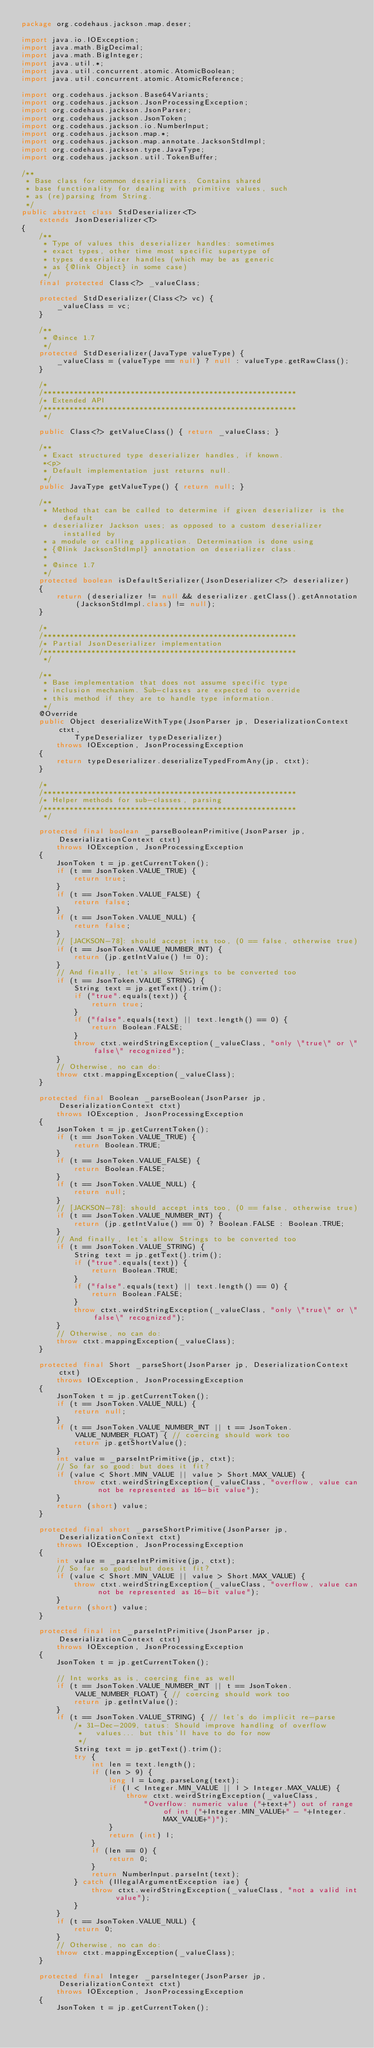<code> <loc_0><loc_0><loc_500><loc_500><_Java_>package org.codehaus.jackson.map.deser;

import java.io.IOException;
import java.math.BigDecimal;
import java.math.BigInteger;
import java.util.*;
import java.util.concurrent.atomic.AtomicBoolean;
import java.util.concurrent.atomic.AtomicReference;

import org.codehaus.jackson.Base64Variants;
import org.codehaus.jackson.JsonProcessingException;
import org.codehaus.jackson.JsonParser;
import org.codehaus.jackson.JsonToken;
import org.codehaus.jackson.io.NumberInput;
import org.codehaus.jackson.map.*;
import org.codehaus.jackson.map.annotate.JacksonStdImpl;
import org.codehaus.jackson.type.JavaType;
import org.codehaus.jackson.util.TokenBuffer;

/**
 * Base class for common deserializers. Contains shared
 * base functionality for dealing with primitive values, such
 * as (re)parsing from String.
 */
public abstract class StdDeserializer<T>
    extends JsonDeserializer<T>
{
    /**
     * Type of values this deserializer handles: sometimes
     * exact types, other time most specific supertype of
     * types deserializer handles (which may be as generic
     * as {@link Object} in some case)
     */
    final protected Class<?> _valueClass;

    protected StdDeserializer(Class<?> vc) {
        _valueClass = vc;
    }

    /**
     * @since 1.7
     */
    protected StdDeserializer(JavaType valueType) {
        _valueClass = (valueType == null) ? null : valueType.getRawClass();
    }
    
    /*
    /**********************************************************
    /* Extended API
    /**********************************************************
     */

    public Class<?> getValueClass() { return _valueClass; }

    /**
     * Exact structured type deserializer handles, if known.
     *<p>
     * Default implementation just returns null.
     */
    public JavaType getValueType() { return null; }

    /**
     * Method that can be called to determine if given deserializer is the default
     * deserializer Jackson uses; as opposed to a custom deserializer installed by
     * a module or calling application. Determination is done using
     * {@link JacksonStdImpl} annotation on deserializer class.
     * 
     * @since 1.7
     */
    protected boolean isDefaultSerializer(JsonDeserializer<?> deserializer)
    {
        return (deserializer != null && deserializer.getClass().getAnnotation(JacksonStdImpl.class) != null);
    }
    
    /*
    /**********************************************************
    /* Partial JsonDeserializer implementation 
    /**********************************************************
     */
    
    /**
     * Base implementation that does not assume specific type
     * inclusion mechanism. Sub-classes are expected to override
     * this method if they are to handle type information.
     */
    @Override
    public Object deserializeWithType(JsonParser jp, DeserializationContext ctxt,
            TypeDeserializer typeDeserializer)
        throws IOException, JsonProcessingException
    {
        return typeDeserializer.deserializeTypedFromAny(jp, ctxt);
    }
    
    /*
    /**********************************************************
    /* Helper methods for sub-classes, parsing
    /**********************************************************
     */

    protected final boolean _parseBooleanPrimitive(JsonParser jp, DeserializationContext ctxt)
        throws IOException, JsonProcessingException
    {
        JsonToken t = jp.getCurrentToken();
        if (t == JsonToken.VALUE_TRUE) {
            return true;
        }
        if (t == JsonToken.VALUE_FALSE) {
            return false;
        }
        if (t == JsonToken.VALUE_NULL) {
            return false;
        }
        // [JACKSON-78]: should accept ints too, (0 == false, otherwise true)
        if (t == JsonToken.VALUE_NUMBER_INT) {
            return (jp.getIntValue() != 0);
        }
        // And finally, let's allow Strings to be converted too
        if (t == JsonToken.VALUE_STRING) {
            String text = jp.getText().trim();
            if ("true".equals(text)) {
                return true;
            }
            if ("false".equals(text) || text.length() == 0) {
                return Boolean.FALSE;
            }
            throw ctxt.weirdStringException(_valueClass, "only \"true\" or \"false\" recognized");
        }
        // Otherwise, no can do:
        throw ctxt.mappingException(_valueClass);
    }

    protected final Boolean _parseBoolean(JsonParser jp, DeserializationContext ctxt)
        throws IOException, JsonProcessingException
    {
        JsonToken t = jp.getCurrentToken();
        if (t == JsonToken.VALUE_TRUE) {
            return Boolean.TRUE;
        }
        if (t == JsonToken.VALUE_FALSE) {
            return Boolean.FALSE;
        }
        if (t == JsonToken.VALUE_NULL) {
            return null;
        }
        // [JACKSON-78]: should accept ints too, (0 == false, otherwise true)
        if (t == JsonToken.VALUE_NUMBER_INT) {
            return (jp.getIntValue() == 0) ? Boolean.FALSE : Boolean.TRUE; 
        }
        // And finally, let's allow Strings to be converted too
        if (t == JsonToken.VALUE_STRING) {
            String text = jp.getText().trim();
            if ("true".equals(text)) {
                return Boolean.TRUE;
            }
            if ("false".equals(text) || text.length() == 0) {
                return Boolean.FALSE;
            }
            throw ctxt.weirdStringException(_valueClass, "only \"true\" or \"false\" recognized");
        }
        // Otherwise, no can do:
        throw ctxt.mappingException(_valueClass);
    }
    
    protected final Short _parseShort(JsonParser jp, DeserializationContext ctxt)
        throws IOException, JsonProcessingException
    {
        JsonToken t = jp.getCurrentToken();
        if (t == JsonToken.VALUE_NULL) {
            return null;
        }
        if (t == JsonToken.VALUE_NUMBER_INT || t == JsonToken.VALUE_NUMBER_FLOAT) { // coercing should work too
            return jp.getShortValue();
        }
        int value = _parseIntPrimitive(jp, ctxt);
        // So far so good: but does it fit?
        if (value < Short.MIN_VALUE || value > Short.MAX_VALUE) {
            throw ctxt.weirdStringException(_valueClass, "overflow, value can not be represented as 16-bit value");
        }
        return (short) value;
    }

    protected final short _parseShortPrimitive(JsonParser jp, DeserializationContext ctxt)
        throws IOException, JsonProcessingException
    {
        int value = _parseIntPrimitive(jp, ctxt);
        // So far so good: but does it fit?
        if (value < Short.MIN_VALUE || value > Short.MAX_VALUE) {
            throw ctxt.weirdStringException(_valueClass, "overflow, value can not be represented as 16-bit value");
        }
        return (short) value;
    }
    
    protected final int _parseIntPrimitive(JsonParser jp, DeserializationContext ctxt)
        throws IOException, JsonProcessingException
    {
        JsonToken t = jp.getCurrentToken();

        // Int works as is, coercing fine as well
        if (t == JsonToken.VALUE_NUMBER_INT || t == JsonToken.VALUE_NUMBER_FLOAT) { // coercing should work too
            return jp.getIntValue();
        }
        if (t == JsonToken.VALUE_STRING) { // let's do implicit re-parse
            /* 31-Dec-2009, tatus: Should improve handling of overflow
             *   values... but this'll have to do for now
             */
            String text = jp.getText().trim();
            try {
                int len = text.length();
                if (len > 9) {
                    long l = Long.parseLong(text);
                    if (l < Integer.MIN_VALUE || l > Integer.MAX_VALUE) {
                        throw ctxt.weirdStringException(_valueClass,
                            "Overflow: numeric value ("+text+") out of range of int ("+Integer.MIN_VALUE+" - "+Integer.MAX_VALUE+")");
                    }
                    return (int) l;
                }
                if (len == 0) {
                    return 0;
                }
                return NumberInput.parseInt(text);
            } catch (IllegalArgumentException iae) {
                throw ctxt.weirdStringException(_valueClass, "not a valid int value");
            }
        }
        if (t == JsonToken.VALUE_NULL) {
            return 0;
        }
        // Otherwise, no can do:
        throw ctxt.mappingException(_valueClass);
    }

    protected final Integer _parseInteger(JsonParser jp, DeserializationContext ctxt)
        throws IOException, JsonProcessingException
    {
        JsonToken t = jp.getCurrentToken();</code> 